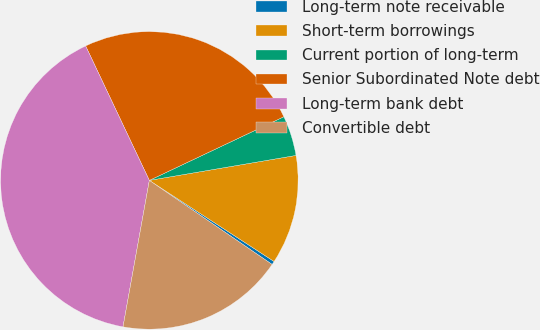Convert chart. <chart><loc_0><loc_0><loc_500><loc_500><pie_chart><fcel>Long-term note receivable<fcel>Short-term borrowings<fcel>Current portion of long-term<fcel>Senior Subordinated Note debt<fcel>Long-term bank debt<fcel>Convertible debt<nl><fcel>0.38%<fcel>11.86%<fcel>4.35%<fcel>25.01%<fcel>40.13%<fcel>18.28%<nl></chart> 